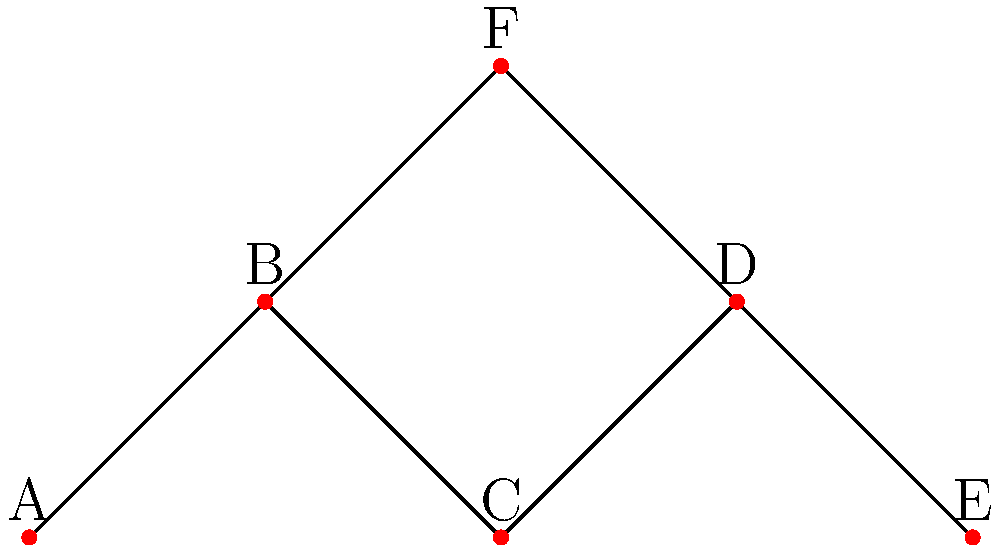After years of losing touch, you want to reconnect with Alice and your old friend group. The graph represents the current connections between friends, where each vertex is a person and each edge represents two people who are already in contact. You decide to use a minimum spanning tree approach to minimize the number of introductions needed. How many introductions are required to ensure everyone in the group is connected? To solve this problem, we need to find the minimum spanning tree (MST) of the given graph. The MST will represent the minimum number of connections needed to ensure everyone in the group is connected. The number of introductions required will be the number of edges in the MST minus the number of existing connections.

Steps to solve:
1. Count the number of vertices (people) in the graph: 6 (A, B, C, D, E, F)
2. Count the number of existing connections (edges): 6
3. Calculate the number of edges needed in the MST:
   - In a tree, the number of edges is always one less than the number of vertices
   - Number of edges in MST = 6 - 1 = 5
4. Calculate the number of introductions needed:
   - Introductions = Edges in MST - Existing connections
   - Introductions = 5 - 6 = -1

Since we get a negative number, it means that no additional introductions are needed. The existing connections already form a spanning tree, connecting all members of the group.
Answer: 0 introductions 